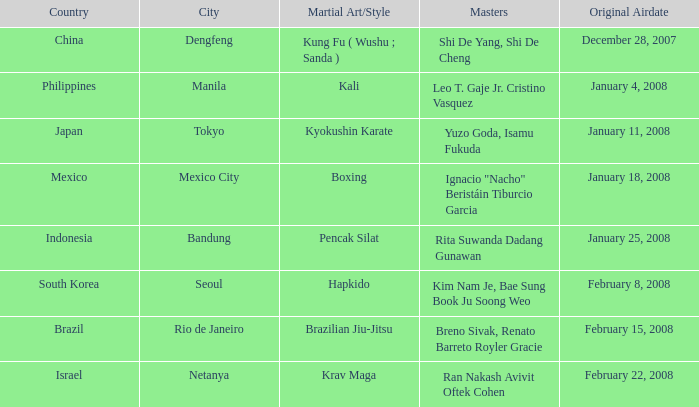How many masters fought using a boxing style? 1.0. 